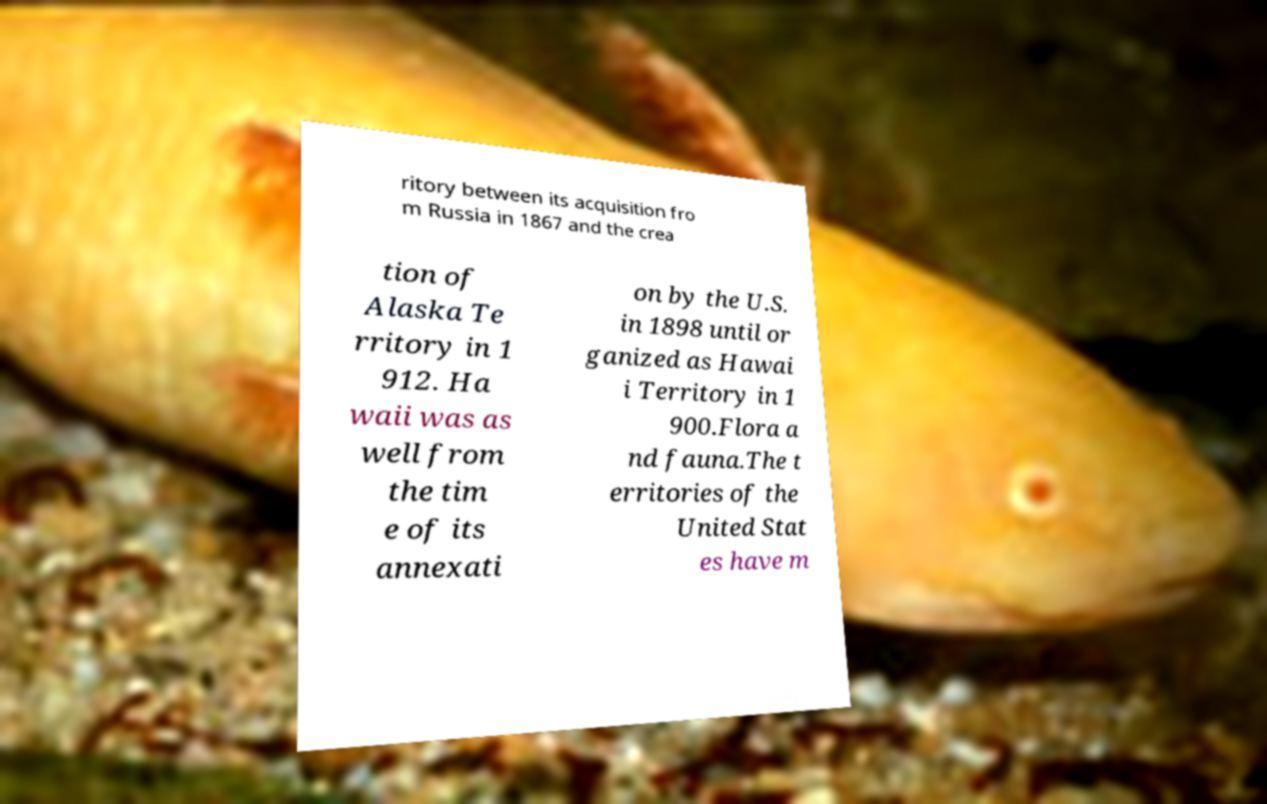Please read and relay the text visible in this image. What does it say? ritory between its acquisition fro m Russia in 1867 and the crea tion of Alaska Te rritory in 1 912. Ha waii was as well from the tim e of its annexati on by the U.S. in 1898 until or ganized as Hawai i Territory in 1 900.Flora a nd fauna.The t erritories of the United Stat es have m 